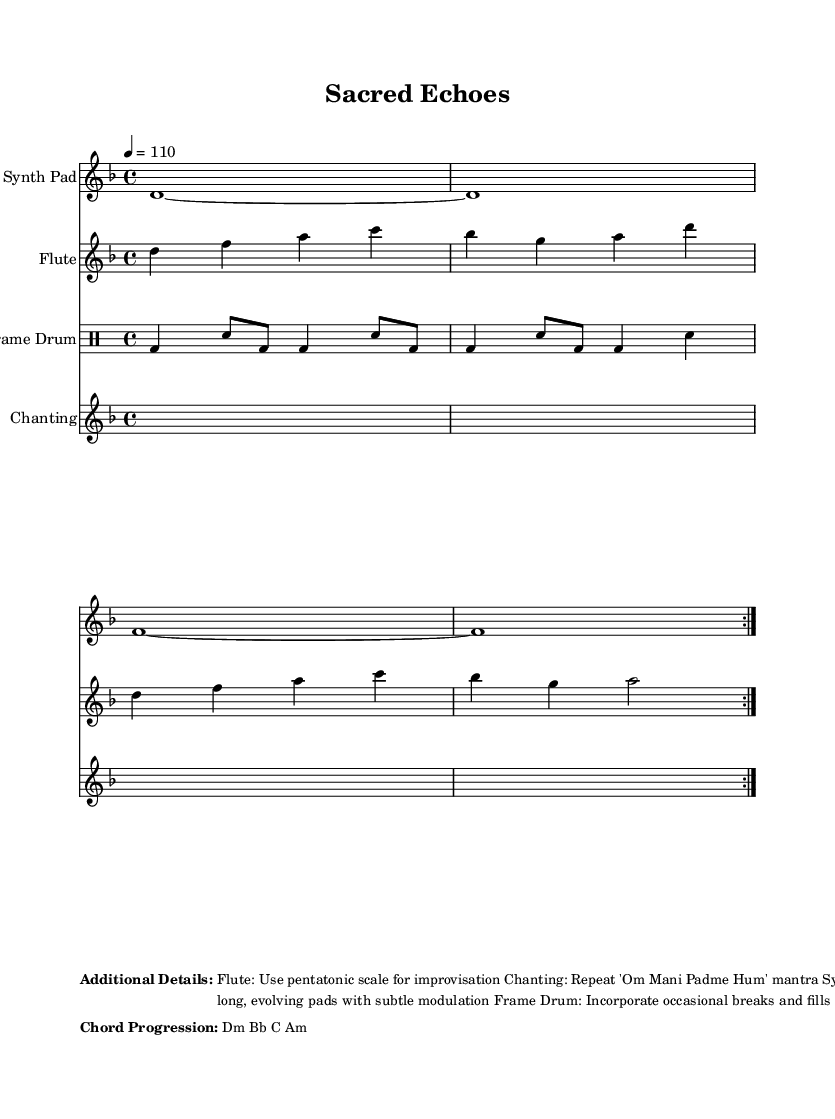What is the key signature of this music? The key signature is indicated by the accidental symbols on the staff. In this piece, there are two flats present (B and E), indicating that it is in the key of D minor.
Answer: D minor What is the time signature of this music? The time signature is shown at the beginning of the piece, represented by the numbers in a fraction format. Here, it shows 4 over 4, meaning there are four beats in each measure and the quarter note gets one beat.
Answer: 4/4 What is the tempo marking for this piece? The tempo marking is provided in beats per minute (BPM) notation, located above the staff at the beginning of the score. The marking states "4 = 110", meaning each quarter note is played at a speed of 110 beats per minute.
Answer: 110 How many measures does the synth pad repeat? The repeat symbol (volta) at the beginning of the synth pad indicates that it repeats two times. Counting the measures in the repeated section confirms there are four measures to be repeated.
Answer: 2 What is the main chant used in this piece? The lyrics section of the score shows the text that will be sung by the voices. The repeated phrase "Om Mani Padme Hum" indicates this is the mantra used throughout the piece.
Answer: Om Mani Padme Hum Which instrument plays the frame drum? The header above the drum part clearly identifies the instrument. The label "Frame Drum" states which instrument is playing this percussion part.
Answer: Frame Drum What scale is suggested for flute improvisation? The additional details section under the score mentions improvisation advice for the flute part, specifically stating to use the pentatonic scale. This is a common scale used in various musical traditions, especially in spiritual music.
Answer: Pentatonic scale 